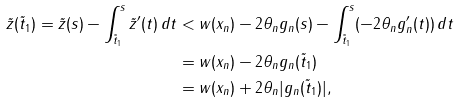<formula> <loc_0><loc_0><loc_500><loc_500>\tilde { z } ( \tilde { t } _ { 1 } ) = \tilde { z } ( s ) - \int _ { \tilde { t } _ { 1 } } ^ { s } \tilde { z } ^ { \prime } ( t ) \, d t & < w ( x _ { n } ) - 2 \theta _ { n } g _ { n } ( s ) - \int _ { \tilde { t } _ { 1 } } ^ { s } ( - 2 \theta _ { n } g _ { n } ^ { \prime } ( t ) ) \, d t \\ & = w ( x _ { n } ) - 2 \theta _ { n } g _ { n } ( \tilde { t } _ { 1 } ) \\ & = w ( x _ { n } ) + 2 \theta _ { n } | g _ { n } ( \tilde { t } _ { 1 } ) | ,</formula> 